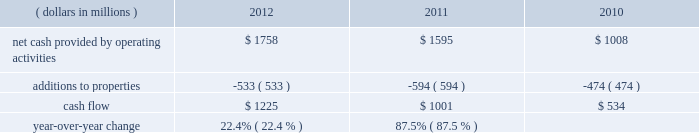We measure cash flow as net cash provided by operating activities reduced by expenditures for property additions .
We use this non-gaap financial measure of cash flow to focus management and investors on the amount of cash available for debt repayment , dividend distributions , acquisition opportunities , and share repurchases .
Our cash flow metric is reconciled to the most comparable gaap measure , as follows: .
Year-over-year change 22.4 % (  % ) 87.5 % (  % ) year-over-year changes in cash flow ( as defined ) were driven by improved performance in working capital resulting from the benefit derived from the pringles acquisition , as well as changes in the level of capital expenditures during the three-year period .
Investing activities our net cash used in investing activities for 2012 amounted to $ 3245 million , an increase of $ 2658 million compared with 2011 primarily attributable to the $ 2668 acquisition of pringles in capital spending in 2012 included investments in our supply chain infrastructure , and to support capacity requirements in certain markets , including pringles .
In addition , we continued the investment in our information technology infrastructure related to the reimplementation and upgrade of our sap platform .
Net cash used in investing activities of $ 587 million in 2011 increased by $ 122 million compared with 2010 , reflecting capital projects for our reimplementation and upgrade of our sap platform and investments in our supply chain .
Cash paid for additions to properties as a percentage of net sales has decreased to 3.8% ( 3.8 % ) in 2012 , from 4.5% ( 4.5 % ) in 2011 , which was an increase from 3.8% ( 3.8 % ) in financing activities in february 2013 , we issued $ 250 million of two-year floating-rate u.s .
Dollar notes , and $ 400 million of ten-year 2.75% ( 2.75 % ) u.s .
Dollar notes .
The proceeds from these notes will be used for general corporate purposes , including , together with cash on hand , repayment of the $ 750 million aggregate principal amount of our 4.25% ( 4.25 % ) u.s .
Dollar notes due march 2013 .
The floating-rate notes bear interest equal to three-month libor plus 23 basis points , subject to quarterly reset .
The notes contain customary covenants that limit the ability of kellogg company and its restricted subsidiaries ( as defined ) to incur certain liens or enter into certain sale and lease-back transactions , as well as a change of control provision .
Our net cash provided by financing activities was $ 1317 for 2012 , compared to net cash used in financing activities of $ 957 and $ 439 for 2011 and 2010 , respectively .
The increase in cash provided from financing activities in 2012 compared to 2011 and 2010 , was primarily due to the issuance of debt related to the acquisition of pringles .
Total debt was $ 7.9 billion at year-end 2012 and $ 6.0 billion at year-end 2011 .
In march 2012 , we entered into interest rate swaps on our $ 500 million five-year 1.875% ( 1.875 % ) fixed rate u.s .
Dollar notes due 2016 , $ 500 million ten-year 4.15% ( 4.15 % ) fixed rate u.s .
Dollar notes due 2019 and $ 500 million of our $ 750 million seven-year 4.45% ( 4.45 % ) fixed rate u.s .
Dollar notes due 2016 .
The interest rate swaps effectively converted these notes from their fixed rates to floating rate obligations through maturity .
In may 2012 , we issued $ 350 million of three-year 1.125% ( 1.125 % ) u.s .
Dollar notes , $ 400 million of five-year 1.75% ( 1.75 % ) u.s .
Dollar notes and $ 700 million of ten-year 3.125% ( 3.125 % ) u.s .
Dollar notes , resulting in aggregate net proceeds after debt discount of $ 1.442 billion .
The proceeds of these notes were used for general corporate purposes , including financing a portion of the acquisition of pringles .
In may 2012 , we issued cdn .
$ 300 million of two-year 2.10% ( 2.10 % ) fixed rate canadian dollar notes , using the proceeds from these notes for general corporate purposes , which included repayment of intercompany debt .
This repayment resulted in cash available to be used for a portion of the acquisition of pringles .
In december 2012 , we repaid $ 750 million five-year 5.125% ( 5.125 % ) u.s .
Dollar notes at maturity with commercial paper .
In february 2011 , we entered into interest rate swaps on $ 200 million of our $ 750 million seven-year 4.45% ( 4.45 % ) fixed rate u.s .
Dollar notes due 2016 .
The interest rate swaps effectively converted this portion of the notes from a fixed rate to a floating rate obligation through maturity .
In april 2011 , we repaid $ 945 million ten-year 6.60% ( 6.60 % ) u.s .
Dollar notes at maturity with commercial paper .
In may 2011 , we issued $ 400 million of seven-year 3.25% ( 3.25 % ) fixed rate u.s .
Dollar notes , using the proceeds of $ 397 million for general corporate purposes and repayment of commercial paper .
During 2011 , we entered into interest rate swaps with notional amounts totaling $ 400 million , which effectively converted these notes from a fixed rate to a floating rate obligation through maturity .
In november 2011 , we issued $ 500 million of five-year 1.875% ( 1.875 % ) fixed rate u .
Dollar notes , using the proceeds of $ 498 million for general corporate purposes and repayment of commercial paper .
During 2012 , we entered into interest rate swaps which effectively converted these notes from a fixed rate to a floating rate obligation through maturity .
In april 2010 , our board of directors approved a share repurchase program authorizing us to repurchase shares of our common stock amounting to $ 2.5 billion during 2010 through 2012 .
This three year authorization replaced previous share buyback programs which had authorized stock repurchases of up to $ 1.1 billion for 2010 and $ 650 million for 2009 .
Under this program , we repurchased approximately 1 million , 15 million and 21 million shares of common stock for $ 63 million , $ 793 million and $ 1.1 billion during 2012 , 2011 and 2010 , respectively .
In december 2012 , our board of directors approved a share repurchase program authorizing us to repurchase shares of our common stock amounting to $ 300 million during 2013 .
We paid quarterly dividends to shareholders totaling $ 1.74 per share in 2012 , $ 1.67 per share in 2011 and $ 1.56 per share in 2010 .
Total cash paid for dividends increased by 3.0% ( 3.0 % ) in 2012 and 3.4% ( 3.4 % ) in 2011 .
In march 2011 , we entered into an unsecured four- year credit agreement which allows us to borrow , on a revolving credit basis , up to $ 2.0 billion .
Our long-term debt agreements contain customary covenants that limit kellogg company and some of its subsidiaries from incurring certain liens or from entering into certain sale and lease-back transactions .
Some agreements also contain change in control provisions .
However , they do not contain acceleration of maturity clauses that are dependent on credit ratings .
A change in our credit ratings could limit our access to the u.s .
Short-term debt market and/or increase the cost of refinancing long-term debt in the future .
However , even under these circumstances , we would continue to have access to our four-year credit agreement , which expires in march 2015 .
This source of liquidity is unused and available on an unsecured basis , although we do not currently plan to use it .
Capital and credit markets , including commercial paper markets , continued to experience instability and disruption as the u.s .
And global economies underwent a period of extreme uncertainty .
Throughout this period of uncertainty , we continued to have access to the u.s. , european , and canadian commercial paper markets .
Our commercial paper and term debt credit ratings were not affected by the changes in the credit environment .
We monitor the financial strength of our third-party financial institutions , including those that hold our cash and cash equivalents as well as those who serve as counterparties to our credit facilities , our derivative financial instruments , and other arrangements .
We are in compliance with all covenants as of december 29 , 2012 .
We continue to believe that we will be able to meet our interest and principal repayment obligations and maintain our debt covenants for the foreseeable future , while still meeting our operational needs , including the pursuit of selected bolt-on acquisitions .
This will be accomplished through our strong cash flow , our short- term borrowings , and our maintenance of credit facilities on a global basis. .
What was the average cash flow from 2010 to 2012? 
Computations: ((534 + (1225 + 1001)) / 3)
Answer: 920.0. 